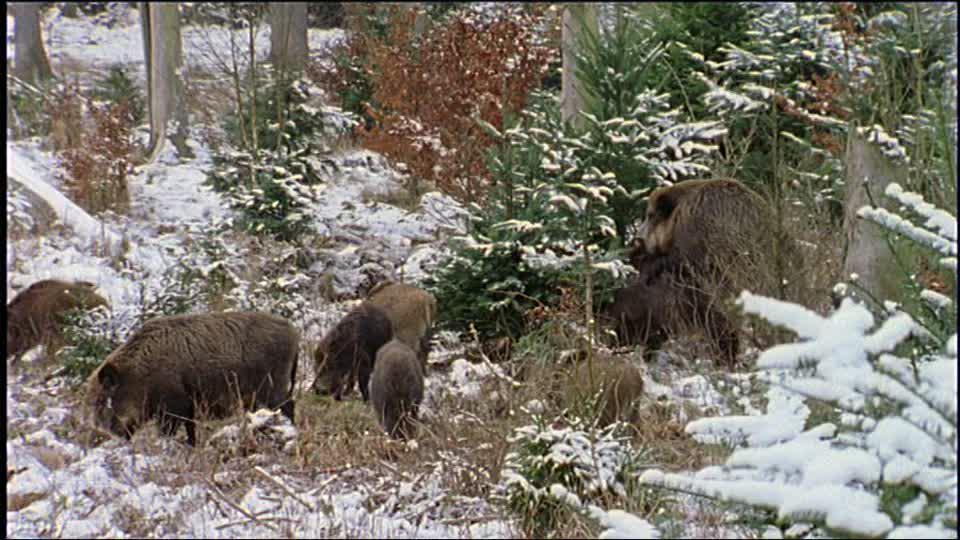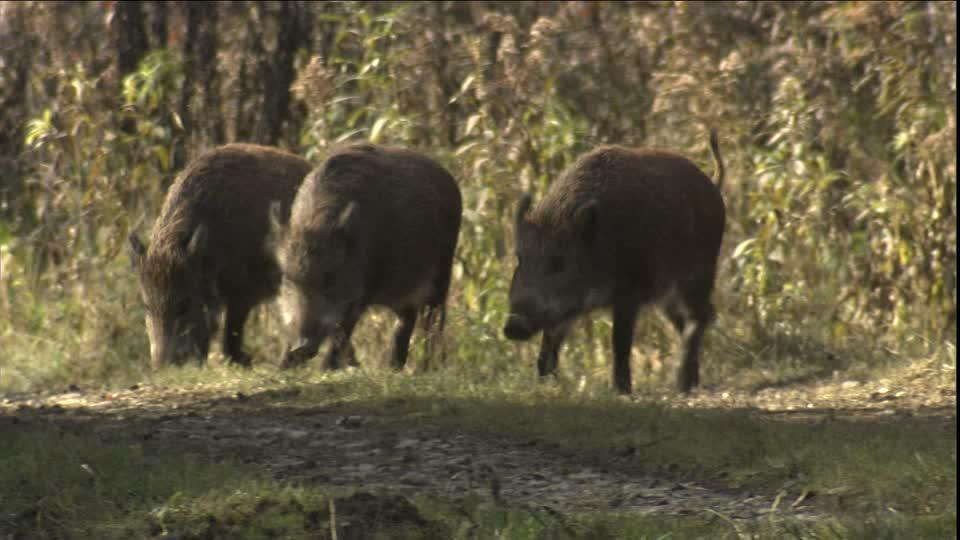The first image is the image on the left, the second image is the image on the right. Evaluate the accuracy of this statement regarding the images: "There is at most three wild pigs in the right image.". Is it true? Answer yes or no. Yes. 